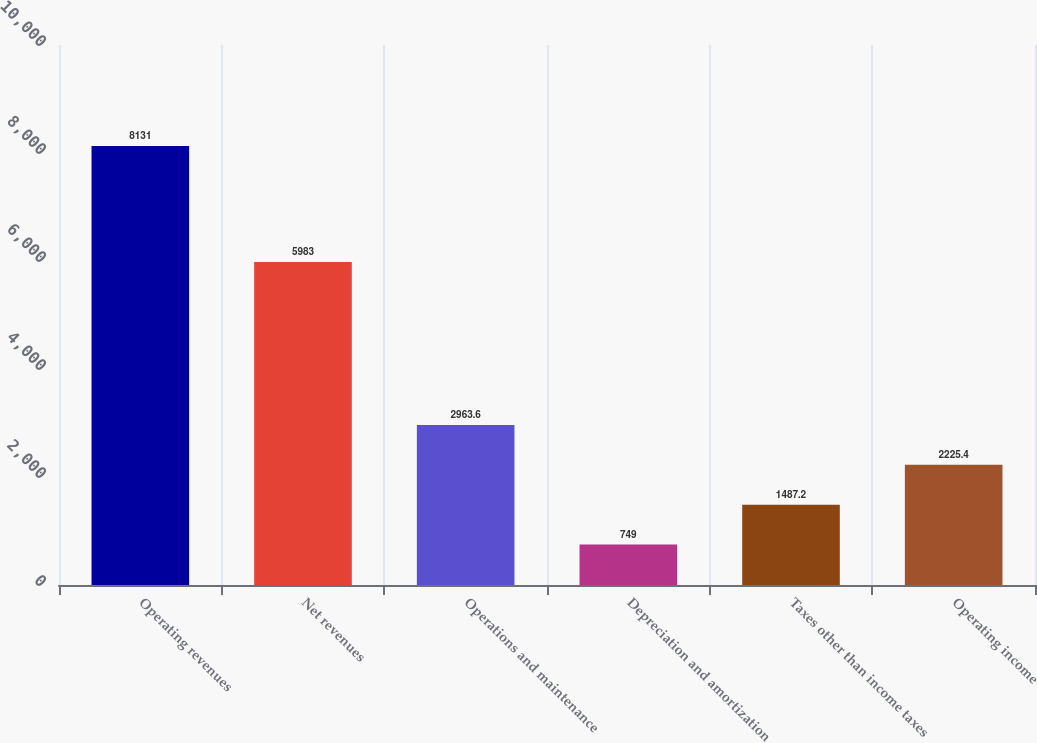Convert chart. <chart><loc_0><loc_0><loc_500><loc_500><bar_chart><fcel>Operating revenues<fcel>Net revenues<fcel>Operations and maintenance<fcel>Depreciation and amortization<fcel>Taxes other than income taxes<fcel>Operating income<nl><fcel>8131<fcel>5983<fcel>2963.6<fcel>749<fcel>1487.2<fcel>2225.4<nl></chart> 